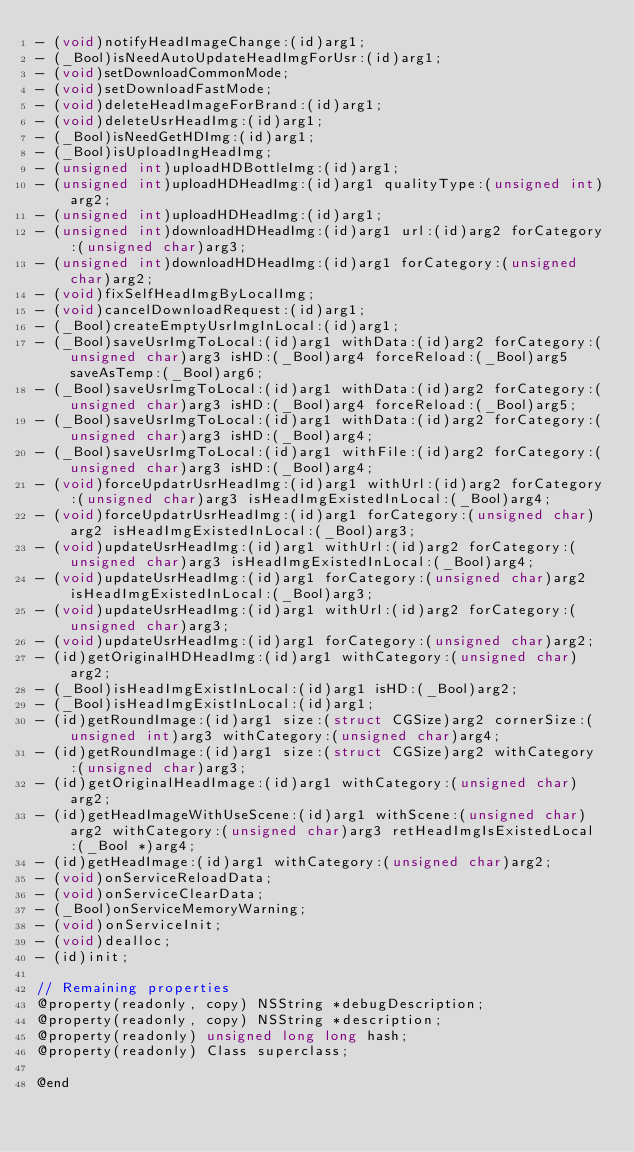<code> <loc_0><loc_0><loc_500><loc_500><_C_>- (void)notifyHeadImageChange:(id)arg1;
- (_Bool)isNeedAutoUpdateHeadImgForUsr:(id)arg1;
- (void)setDownloadCommonMode;
- (void)setDownloadFastMode;
- (void)deleteHeadImageForBrand:(id)arg1;
- (void)deleteUsrHeadImg:(id)arg1;
- (_Bool)isNeedGetHDImg:(id)arg1;
- (_Bool)isUploadIngHeadImg;
- (unsigned int)uploadHDBottleImg:(id)arg1;
- (unsigned int)uploadHDHeadImg:(id)arg1 qualityType:(unsigned int)arg2;
- (unsigned int)uploadHDHeadImg:(id)arg1;
- (unsigned int)downloadHDHeadImg:(id)arg1 url:(id)arg2 forCategory:(unsigned char)arg3;
- (unsigned int)downloadHDHeadImg:(id)arg1 forCategory:(unsigned char)arg2;
- (void)fixSelfHeadImgByLocalImg;
- (void)cancelDownloadRequest:(id)arg1;
- (_Bool)createEmptyUsrImgInLocal:(id)arg1;
- (_Bool)saveUsrImgToLocal:(id)arg1 withData:(id)arg2 forCategory:(unsigned char)arg3 isHD:(_Bool)arg4 forceReload:(_Bool)arg5 saveAsTemp:(_Bool)arg6;
- (_Bool)saveUsrImgToLocal:(id)arg1 withData:(id)arg2 forCategory:(unsigned char)arg3 isHD:(_Bool)arg4 forceReload:(_Bool)arg5;
- (_Bool)saveUsrImgToLocal:(id)arg1 withData:(id)arg2 forCategory:(unsigned char)arg3 isHD:(_Bool)arg4;
- (_Bool)saveUsrImgToLocal:(id)arg1 withFile:(id)arg2 forCategory:(unsigned char)arg3 isHD:(_Bool)arg4;
- (void)forceUpdatrUsrHeadImg:(id)arg1 withUrl:(id)arg2 forCategory:(unsigned char)arg3 isHeadImgExistedInLocal:(_Bool)arg4;
- (void)forceUpdatrUsrHeadImg:(id)arg1 forCategory:(unsigned char)arg2 isHeadImgExistedInLocal:(_Bool)arg3;
- (void)updateUsrHeadImg:(id)arg1 withUrl:(id)arg2 forCategory:(unsigned char)arg3 isHeadImgExistedInLocal:(_Bool)arg4;
- (void)updateUsrHeadImg:(id)arg1 forCategory:(unsigned char)arg2 isHeadImgExistedInLocal:(_Bool)arg3;
- (void)updateUsrHeadImg:(id)arg1 withUrl:(id)arg2 forCategory:(unsigned char)arg3;
- (void)updateUsrHeadImg:(id)arg1 forCategory:(unsigned char)arg2;
- (id)getOriginalHDHeadImg:(id)arg1 withCategory:(unsigned char)arg2;
- (_Bool)isHeadImgExistInLocal:(id)arg1 isHD:(_Bool)arg2;
- (_Bool)isHeadImgExistInLocal:(id)arg1;
- (id)getRoundImage:(id)arg1 size:(struct CGSize)arg2 cornerSize:(unsigned int)arg3 withCategory:(unsigned char)arg4;
- (id)getRoundImage:(id)arg1 size:(struct CGSize)arg2 withCategory:(unsigned char)arg3;
- (id)getOriginalHeadImage:(id)arg1 withCategory:(unsigned char)arg2;
- (id)getHeadImageWithUseScene:(id)arg1 withScene:(unsigned char)arg2 withCategory:(unsigned char)arg3 retHeadImgIsExistedLocal:(_Bool *)arg4;
- (id)getHeadImage:(id)arg1 withCategory:(unsigned char)arg2;
- (void)onServiceReloadData;
- (void)onServiceClearData;
- (_Bool)onServiceMemoryWarning;
- (void)onServiceInit;
- (void)dealloc;
- (id)init;

// Remaining properties
@property(readonly, copy) NSString *debugDescription;
@property(readonly, copy) NSString *description;
@property(readonly) unsigned long long hash;
@property(readonly) Class superclass;

@end

</code> 